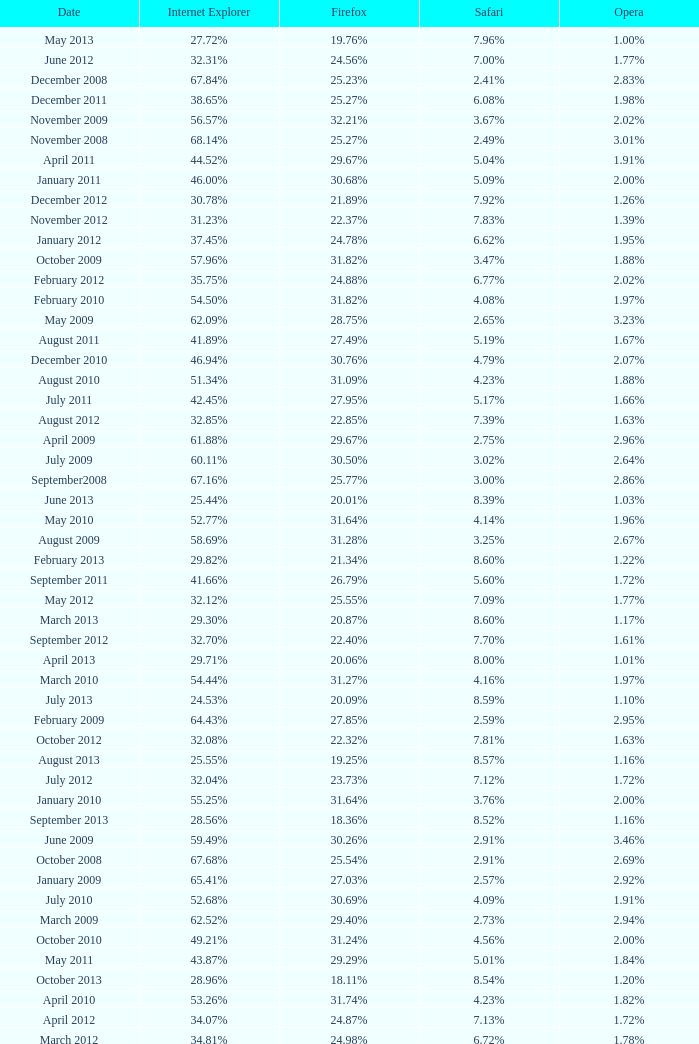What percentage of browsers were using Safari during the period in which 31.27% were using Firefox? 4.16%. 